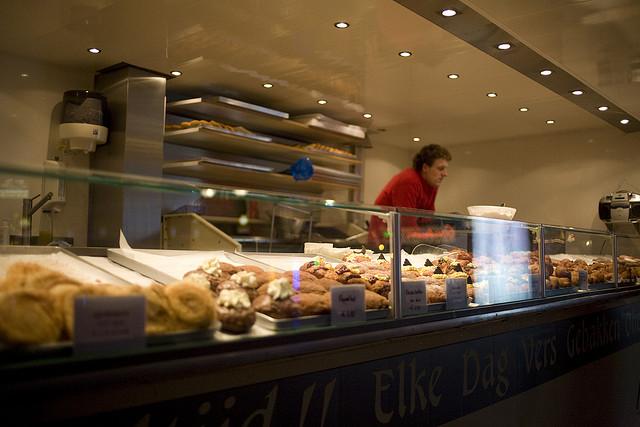What is the image quality?
Concise answer only. Good. What kind of restaurant is this?
Be succinct. Bakery. Are there any customers around?
Answer briefly. No. What types of foods are being sold?
Be succinct. Pastries. 